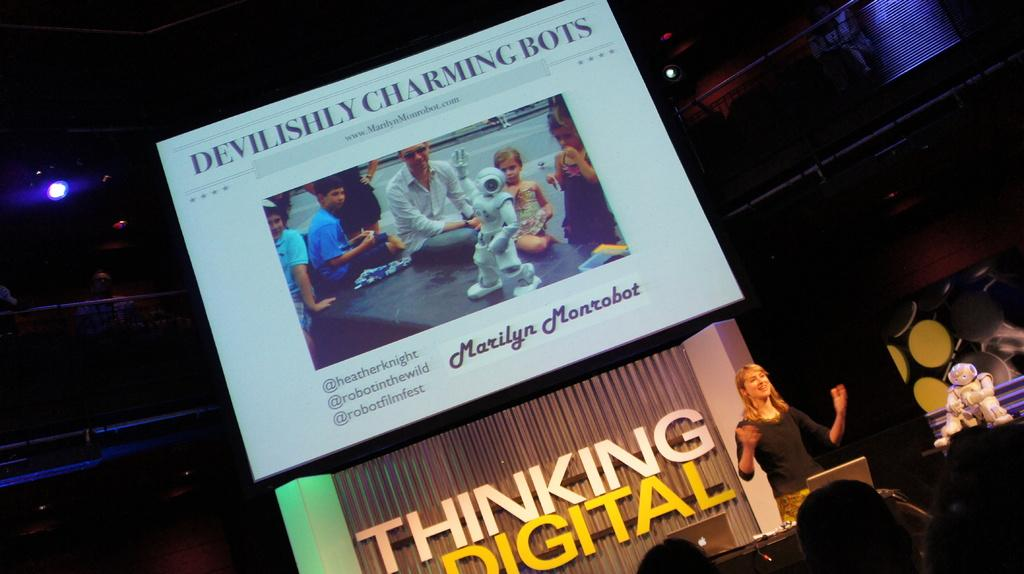<image>
Write a terse but informative summary of the picture. A lecturer delivers a talk on the subject of robots. 